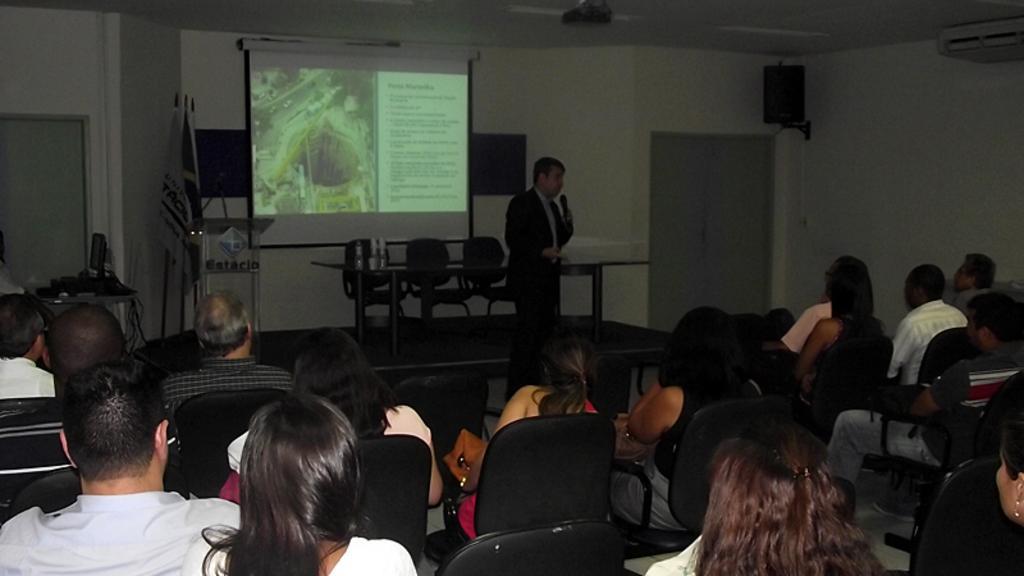In one or two sentences, can you explain what this image depicts? In the center of the image there is a person standing with mic. At the bottom of the image we can see persons sitting on the chairs. In the background we can see chairs, table, doors, speaker, screen and wall. 